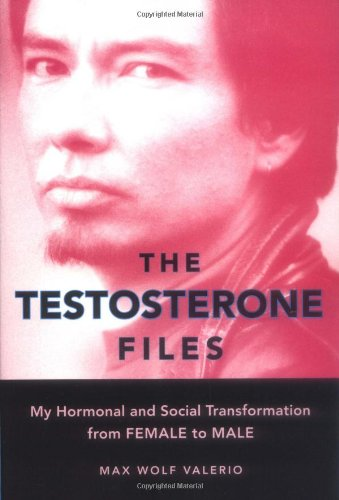What is the title of this book? The book is titled 'The Testosterone Files: My Hormonal and Social Transformation from Female to Male', a poignant memoir detailing the author's personal journey. 